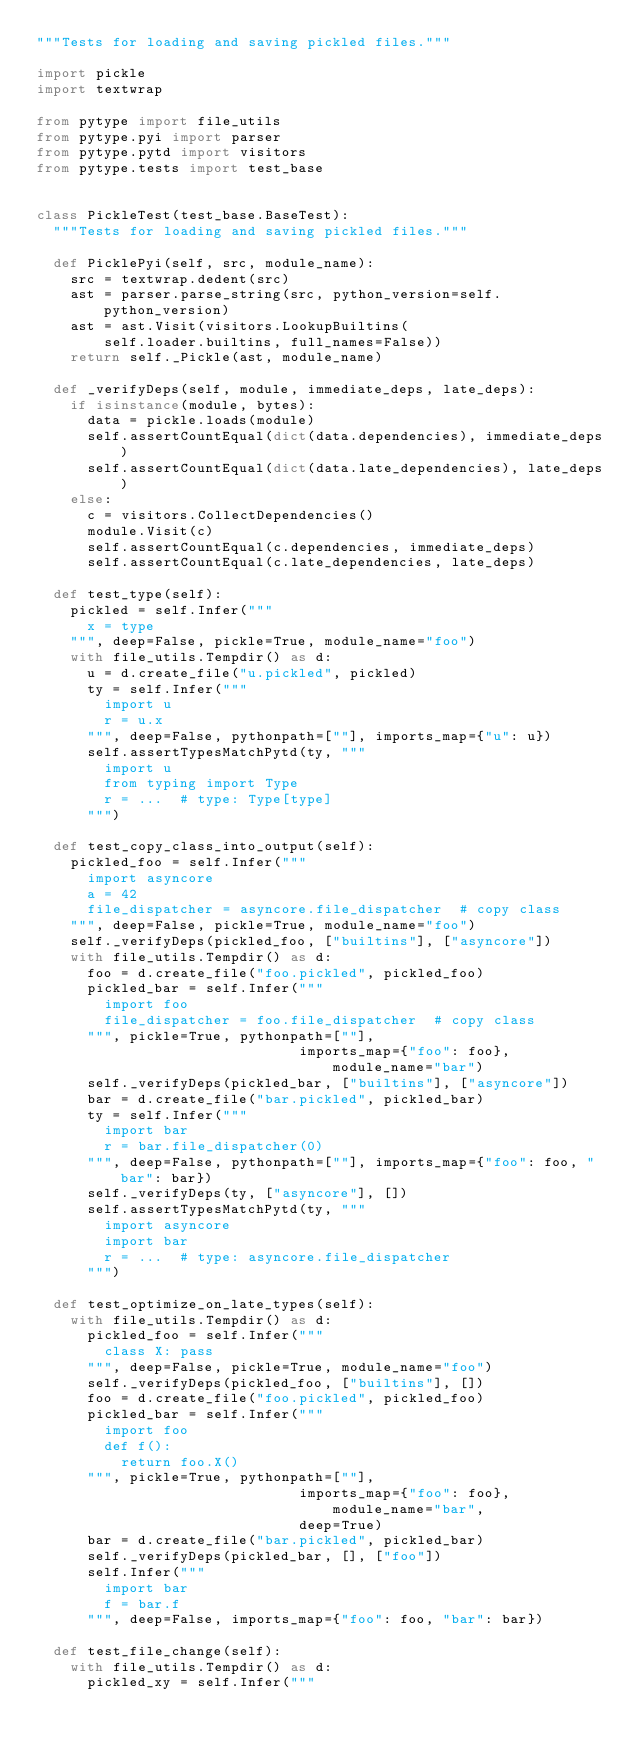<code> <loc_0><loc_0><loc_500><loc_500><_Python_>"""Tests for loading and saving pickled files."""

import pickle
import textwrap

from pytype import file_utils
from pytype.pyi import parser
from pytype.pytd import visitors
from pytype.tests import test_base


class PickleTest(test_base.BaseTest):
  """Tests for loading and saving pickled files."""

  def PicklePyi(self, src, module_name):
    src = textwrap.dedent(src)
    ast = parser.parse_string(src, python_version=self.python_version)
    ast = ast.Visit(visitors.LookupBuiltins(
        self.loader.builtins, full_names=False))
    return self._Pickle(ast, module_name)

  def _verifyDeps(self, module, immediate_deps, late_deps):
    if isinstance(module, bytes):
      data = pickle.loads(module)
      self.assertCountEqual(dict(data.dependencies), immediate_deps)
      self.assertCountEqual(dict(data.late_dependencies), late_deps)
    else:
      c = visitors.CollectDependencies()
      module.Visit(c)
      self.assertCountEqual(c.dependencies, immediate_deps)
      self.assertCountEqual(c.late_dependencies, late_deps)

  def test_type(self):
    pickled = self.Infer("""
      x = type
    """, deep=False, pickle=True, module_name="foo")
    with file_utils.Tempdir() as d:
      u = d.create_file("u.pickled", pickled)
      ty = self.Infer("""
        import u
        r = u.x
      """, deep=False, pythonpath=[""], imports_map={"u": u})
      self.assertTypesMatchPytd(ty, """
        import u
        from typing import Type
        r = ...  # type: Type[type]
      """)

  def test_copy_class_into_output(self):
    pickled_foo = self.Infer("""
      import asyncore
      a = 42
      file_dispatcher = asyncore.file_dispatcher  # copy class
    """, deep=False, pickle=True, module_name="foo")
    self._verifyDeps(pickled_foo, ["builtins"], ["asyncore"])
    with file_utils.Tempdir() as d:
      foo = d.create_file("foo.pickled", pickled_foo)
      pickled_bar = self.Infer("""
        import foo
        file_dispatcher = foo.file_dispatcher  # copy class
      """, pickle=True, pythonpath=[""],
                               imports_map={"foo": foo}, module_name="bar")
      self._verifyDeps(pickled_bar, ["builtins"], ["asyncore"])
      bar = d.create_file("bar.pickled", pickled_bar)
      ty = self.Infer("""
        import bar
        r = bar.file_dispatcher(0)
      """, deep=False, pythonpath=[""], imports_map={"foo": foo, "bar": bar})
      self._verifyDeps(ty, ["asyncore"], [])
      self.assertTypesMatchPytd(ty, """
        import asyncore
        import bar
        r = ...  # type: asyncore.file_dispatcher
      """)

  def test_optimize_on_late_types(self):
    with file_utils.Tempdir() as d:
      pickled_foo = self.Infer("""
        class X: pass
      """, deep=False, pickle=True, module_name="foo")
      self._verifyDeps(pickled_foo, ["builtins"], [])
      foo = d.create_file("foo.pickled", pickled_foo)
      pickled_bar = self.Infer("""
        import foo
        def f():
          return foo.X()
      """, pickle=True, pythonpath=[""],
                               imports_map={"foo": foo}, module_name="bar",
                               deep=True)
      bar = d.create_file("bar.pickled", pickled_bar)
      self._verifyDeps(pickled_bar, [], ["foo"])
      self.Infer("""
        import bar
        f = bar.f
      """, deep=False, imports_map={"foo": foo, "bar": bar})

  def test_file_change(self):
    with file_utils.Tempdir() as d:
      pickled_xy = self.Infer("""</code> 